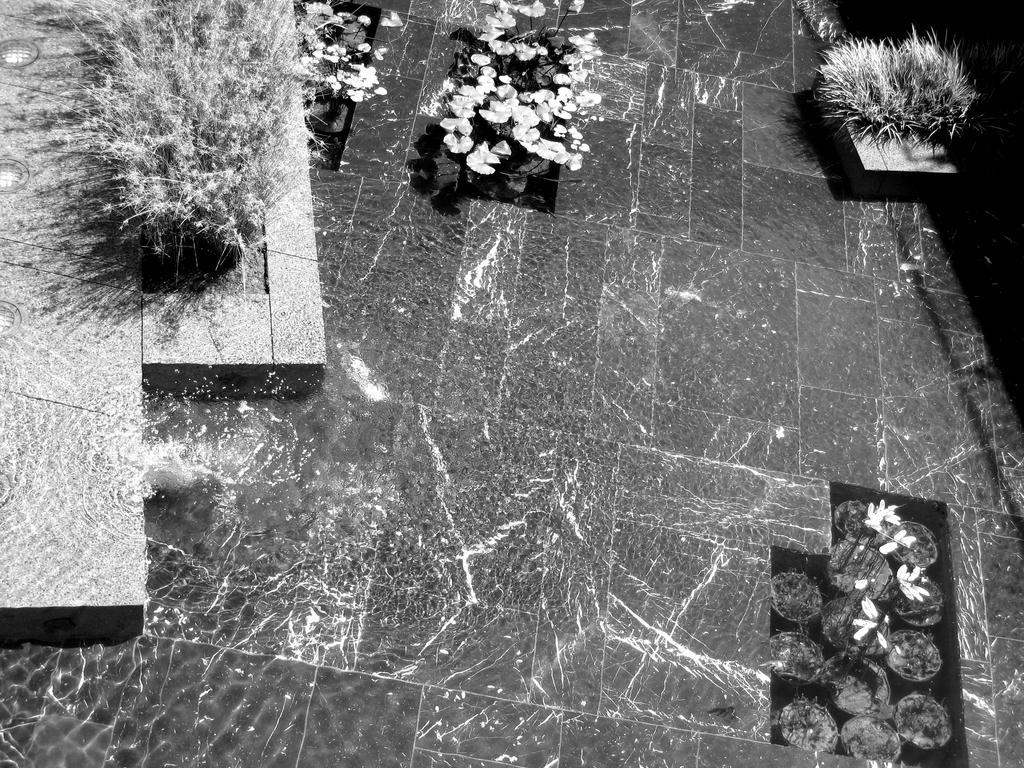Could you give a brief overview of what you see in this image? As we can see in the image there are plants, flowers and pots. 